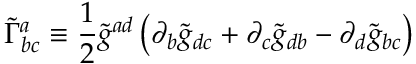<formula> <loc_0><loc_0><loc_500><loc_500>{ \widetilde { \Gamma } } _ { b c } ^ { a } \equiv \frac { 1 } { 2 } { \widetilde { g } } ^ { a d } \left ( \partial _ { b } { \widetilde { g } } _ { d c } + \partial _ { c } { \widetilde { g } } _ { d b } - \partial _ { d } { \widetilde { g } } _ { b c } \right )</formula> 